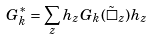Convert formula to latex. <formula><loc_0><loc_0><loc_500><loc_500>G ^ { * } _ { k } = \sum _ { z } h _ { z } G _ { k } ( \tilde { \square } _ { z } ) h _ { z }</formula> 